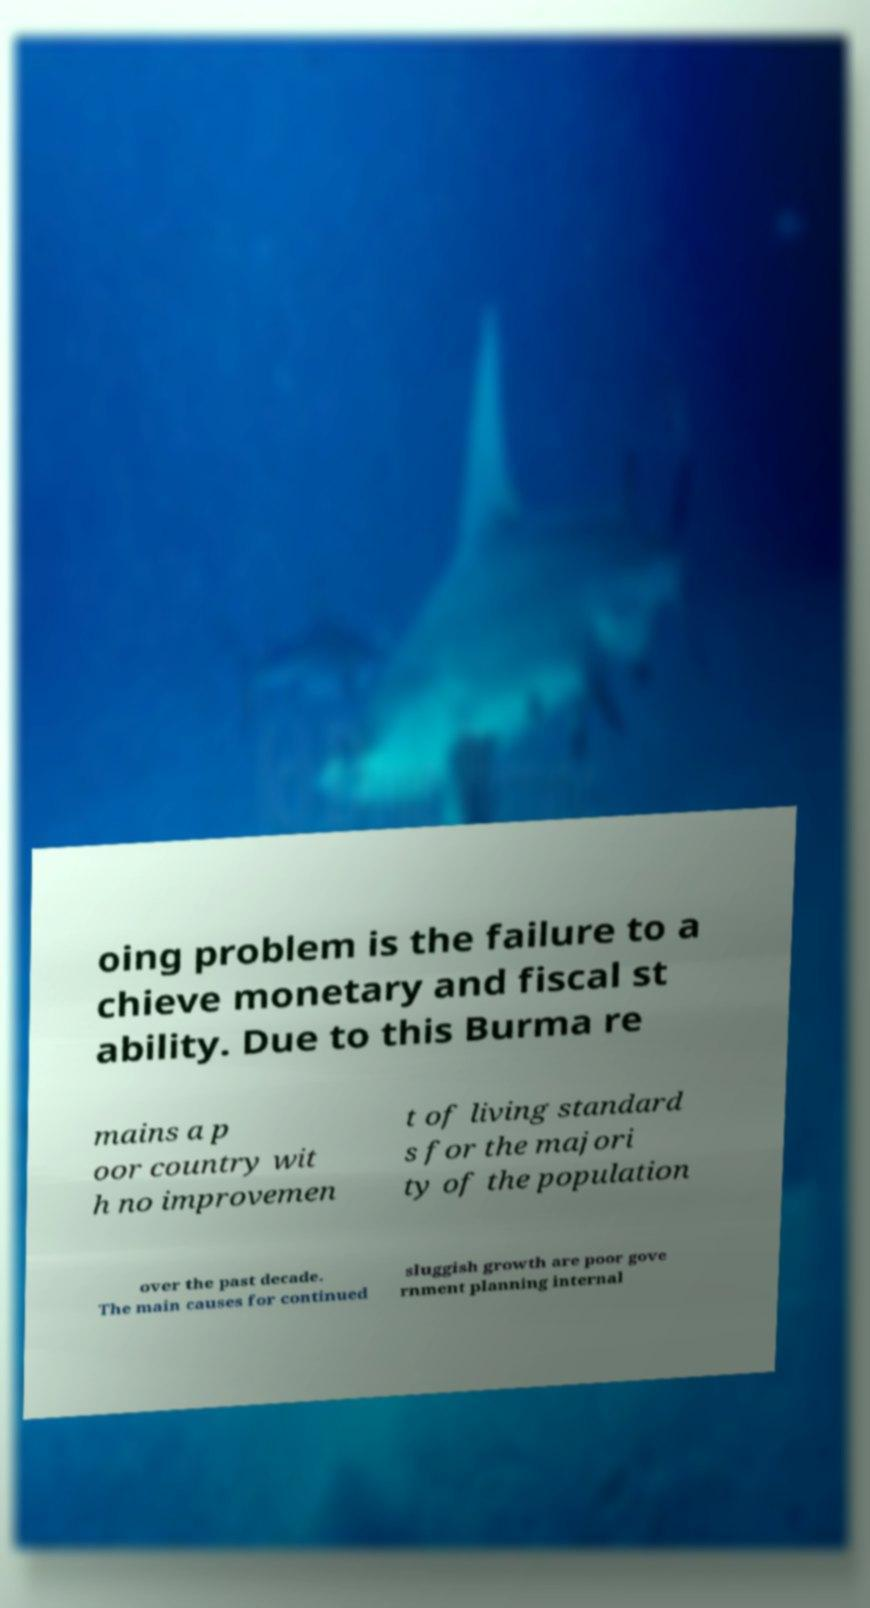What messages or text are displayed in this image? I need them in a readable, typed format. oing problem is the failure to a chieve monetary and fiscal st ability. Due to this Burma re mains a p oor country wit h no improvemen t of living standard s for the majori ty of the population over the past decade. The main causes for continued sluggish growth are poor gove rnment planning internal 